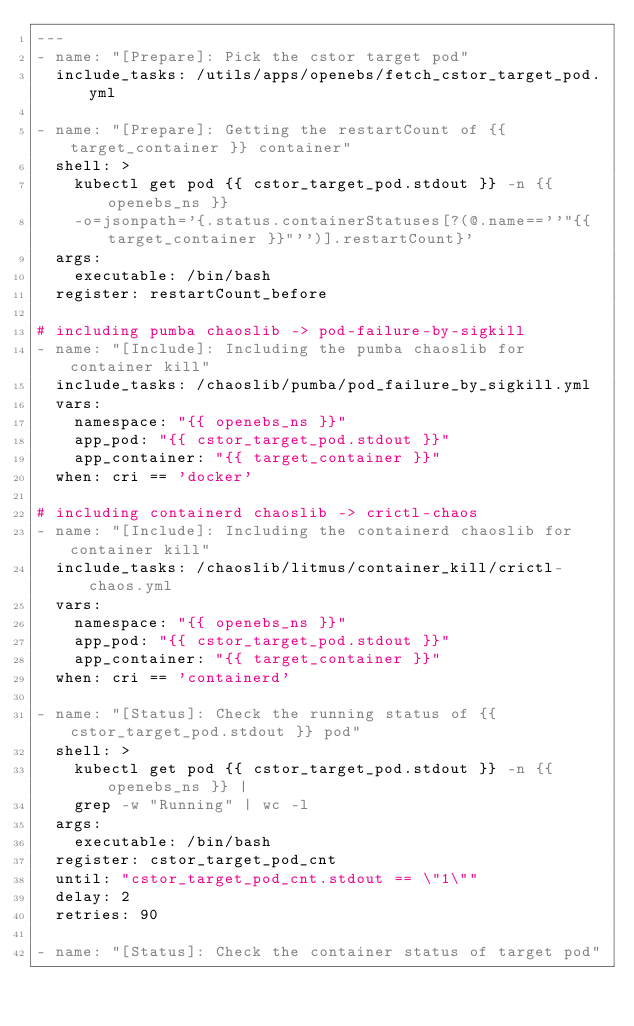<code> <loc_0><loc_0><loc_500><loc_500><_YAML_>---
- name: "[Prepare]: Pick the cstor target pod"
  include_tasks: /utils/apps/openebs/fetch_cstor_target_pod.yml

- name: "[Prepare]: Getting the restartCount of {{ target_container }} container"
  shell: >
    kubectl get pod {{ cstor_target_pod.stdout }} -n {{ openebs_ns }}
    -o=jsonpath='{.status.containerStatuses[?(@.name==''"{{ target_container }}"'')].restartCount}'
  args:
    executable: /bin/bash
  register: restartCount_before

# including pumba chaoslib -> pod-failure-by-sigkill
- name: "[Include]: Including the pumba chaoslib for container kill"
  include_tasks: /chaoslib/pumba/pod_failure_by_sigkill.yml
  vars:
    namespace: "{{ openebs_ns }}"
    app_pod: "{{ cstor_target_pod.stdout }}"
    app_container: "{{ target_container }}"
  when: cri == 'docker'

# including containerd chaoslib -> crictl-chaos
- name: "[Include]: Including the containerd chaoslib for container kill"
  include_tasks: /chaoslib/litmus/container_kill/crictl-chaos.yml
  vars:
    namespace: "{{ openebs_ns }}"
    app_pod: "{{ cstor_target_pod.stdout }}"
    app_container: "{{ target_container }}"
  when: cri == 'containerd'

- name: "[Status]: Check the running status of {{ cstor_target_pod.stdout }} pod"
  shell: >
    kubectl get pod {{ cstor_target_pod.stdout }} -n {{ openebs_ns }} |
    grep -w "Running" | wc -l
  args:
    executable: /bin/bash
  register: cstor_target_pod_cnt
  until: "cstor_target_pod_cnt.stdout == \"1\""
  delay: 2
  retries: 90

- name: "[Status]: Check the container status of target pod"</code> 